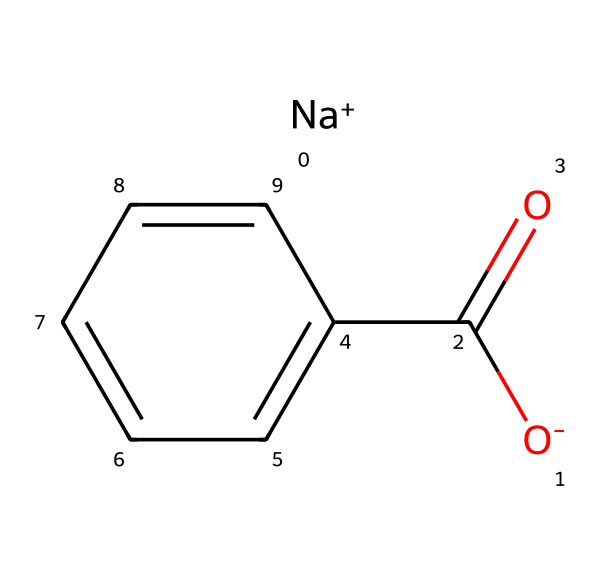What is the primary functional group in sodium benzoate? The chemical structure contains a carboxylate group (the -C(=O)O- part), which is the primary functional group.
Answer: carboxylate How many carbon atoms are present in sodium benzoate? By analyzing the structure, there are 7 carbon atoms in sodium benzoate (6 in the benzene ring and 1 in the carboxylate group).
Answer: 7 What is the oxidation state of the carbon in the carboxylate group? The carbon atom in the carboxylate group is bonded to two oxygen atoms; the oxidation state can be calculated as +1.
Answer: +1 Is sodium benzoate an acid or a base? Sodium benzoate is the sodium salt of benzoic acid, which means it behaves as a weak base in solution.
Answer: base Does sodium benzoate have any aromatic characteristics? Yes, sodium benzoate contains a benzene ring (c1ccccc1), which makes it aromatic due to the delocalization of electrons.
Answer: aromatic What is the total charge of the sodium benzoate molecule? The sodium ion has a +1 charge, and the benzoate part has a -1 charge, making the overall charge zero.
Answer: zero 